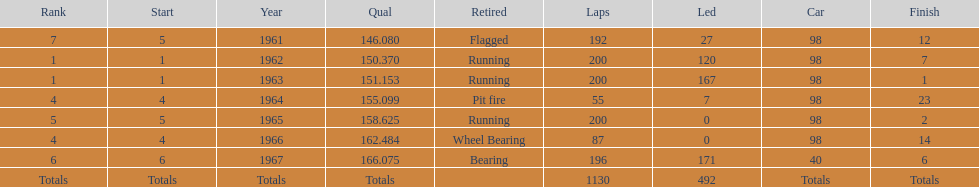What is the difference between the qualfying time in 1967 and 1965? 7.45. 